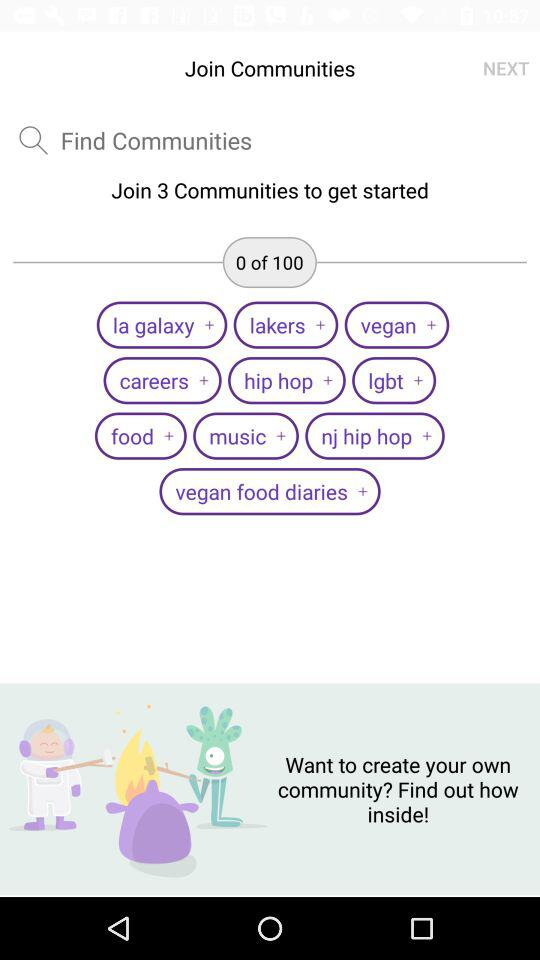Which communities are joined?
When the provided information is insufficient, respond with <no answer>. <no answer> 